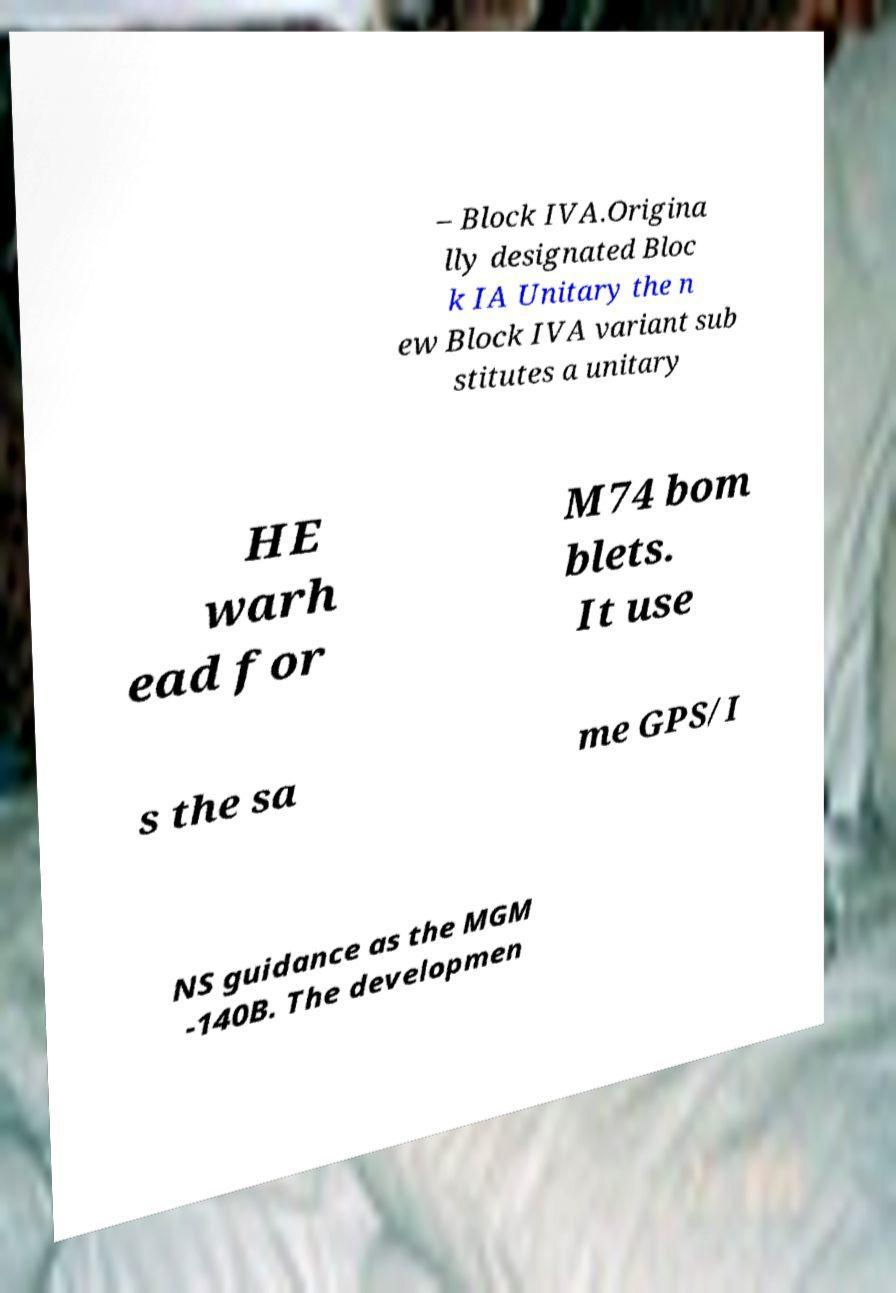Could you assist in decoding the text presented in this image and type it out clearly? – Block IVA.Origina lly designated Bloc k IA Unitary the n ew Block IVA variant sub stitutes a unitary HE warh ead for M74 bom blets. It use s the sa me GPS/I NS guidance as the MGM -140B. The developmen 